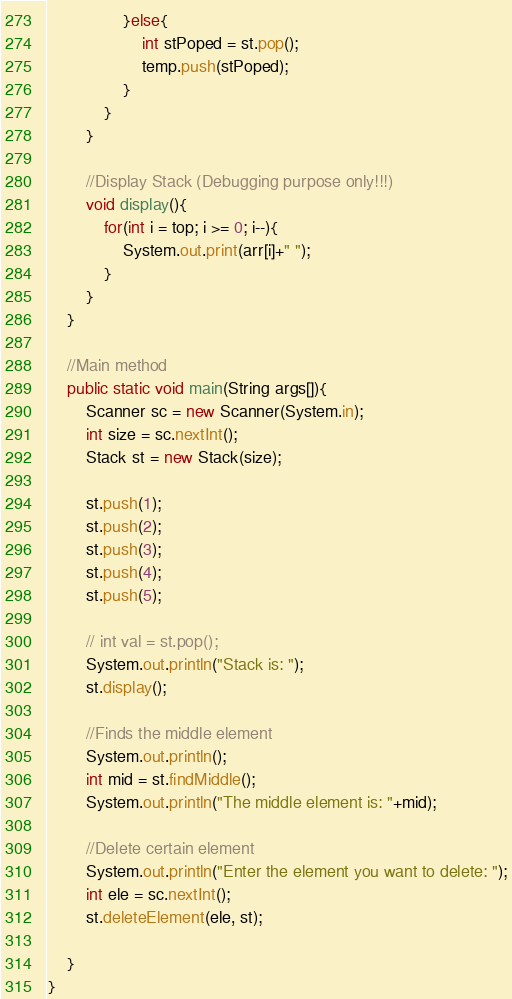Convert code to text. <code><loc_0><loc_0><loc_500><loc_500><_Java_>				}else{
					int stPoped = st.pop();
					temp.push(stPoped);
				}
			}
		}

		//Display Stack (Debugging purpose only!!!)
		void display(){
			for(int i = top; i >= 0; i--){
				System.out.print(arr[i]+" ");
			}
		}
	}

	//Main method
	public static void main(String args[]){
		Scanner sc = new Scanner(System.in);
		int size = sc.nextInt();
		Stack st = new Stack(size);

		st.push(1);
		st.push(2);
		st.push(3);
		st.push(4);
		st.push(5);

		// int val = st.pop();
		System.out.println("Stack is: ");
		st.display();

		//Finds the middle element
		System.out.println();
		int mid = st.findMiddle();
		System.out.println("The middle element is: "+mid);

		//Delete certain element
		System.out.println("Enter the element you want to delete: ");
		int ele = sc.nextInt();
		st.deleteElement(ele, st);

	}	
}</code> 